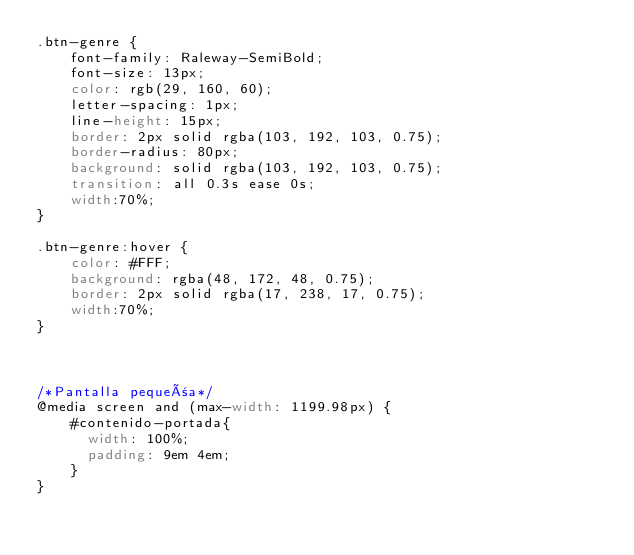<code> <loc_0><loc_0><loc_500><loc_500><_CSS_>.btn-genre {
    font-family: Raleway-SemiBold;
    font-size: 13px;
    color: rgb(29, 160, 60);
    letter-spacing: 1px;
    line-height: 15px;
    border: 2px solid rgba(103, 192, 103, 0.75);
    border-radius: 80px;
    background: solid rgba(103, 192, 103, 0.75);
    transition: all 0.3s ease 0s;
    width:70%; 
}

.btn-genre:hover {
    color: #FFF;
    background: rgba(48, 172, 48, 0.75);
    border: 2px solid rgba(17, 238, 17, 0.75);
    width:70%; 
}



/*Pantalla pequeña*/
@media screen and (max-width: 1199.98px) {
    #contenido-portada{
      width: 100%;
      padding: 9em 4em;
    }
}</code> 